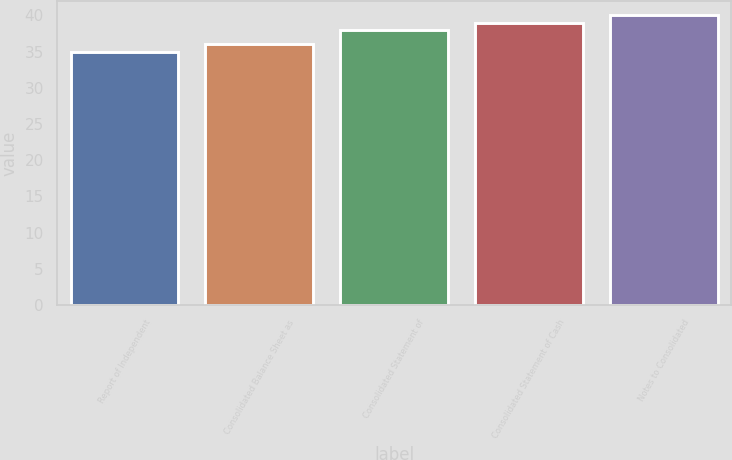Convert chart to OTSL. <chart><loc_0><loc_0><loc_500><loc_500><bar_chart><fcel>Report of Independent<fcel>Consolidated Balance Sheet as<fcel>Consolidated Statement of<fcel>Consolidated Statement of Cash<fcel>Notes to Consolidated<nl><fcel>35<fcel>36<fcel>38<fcel>39<fcel>40<nl></chart> 